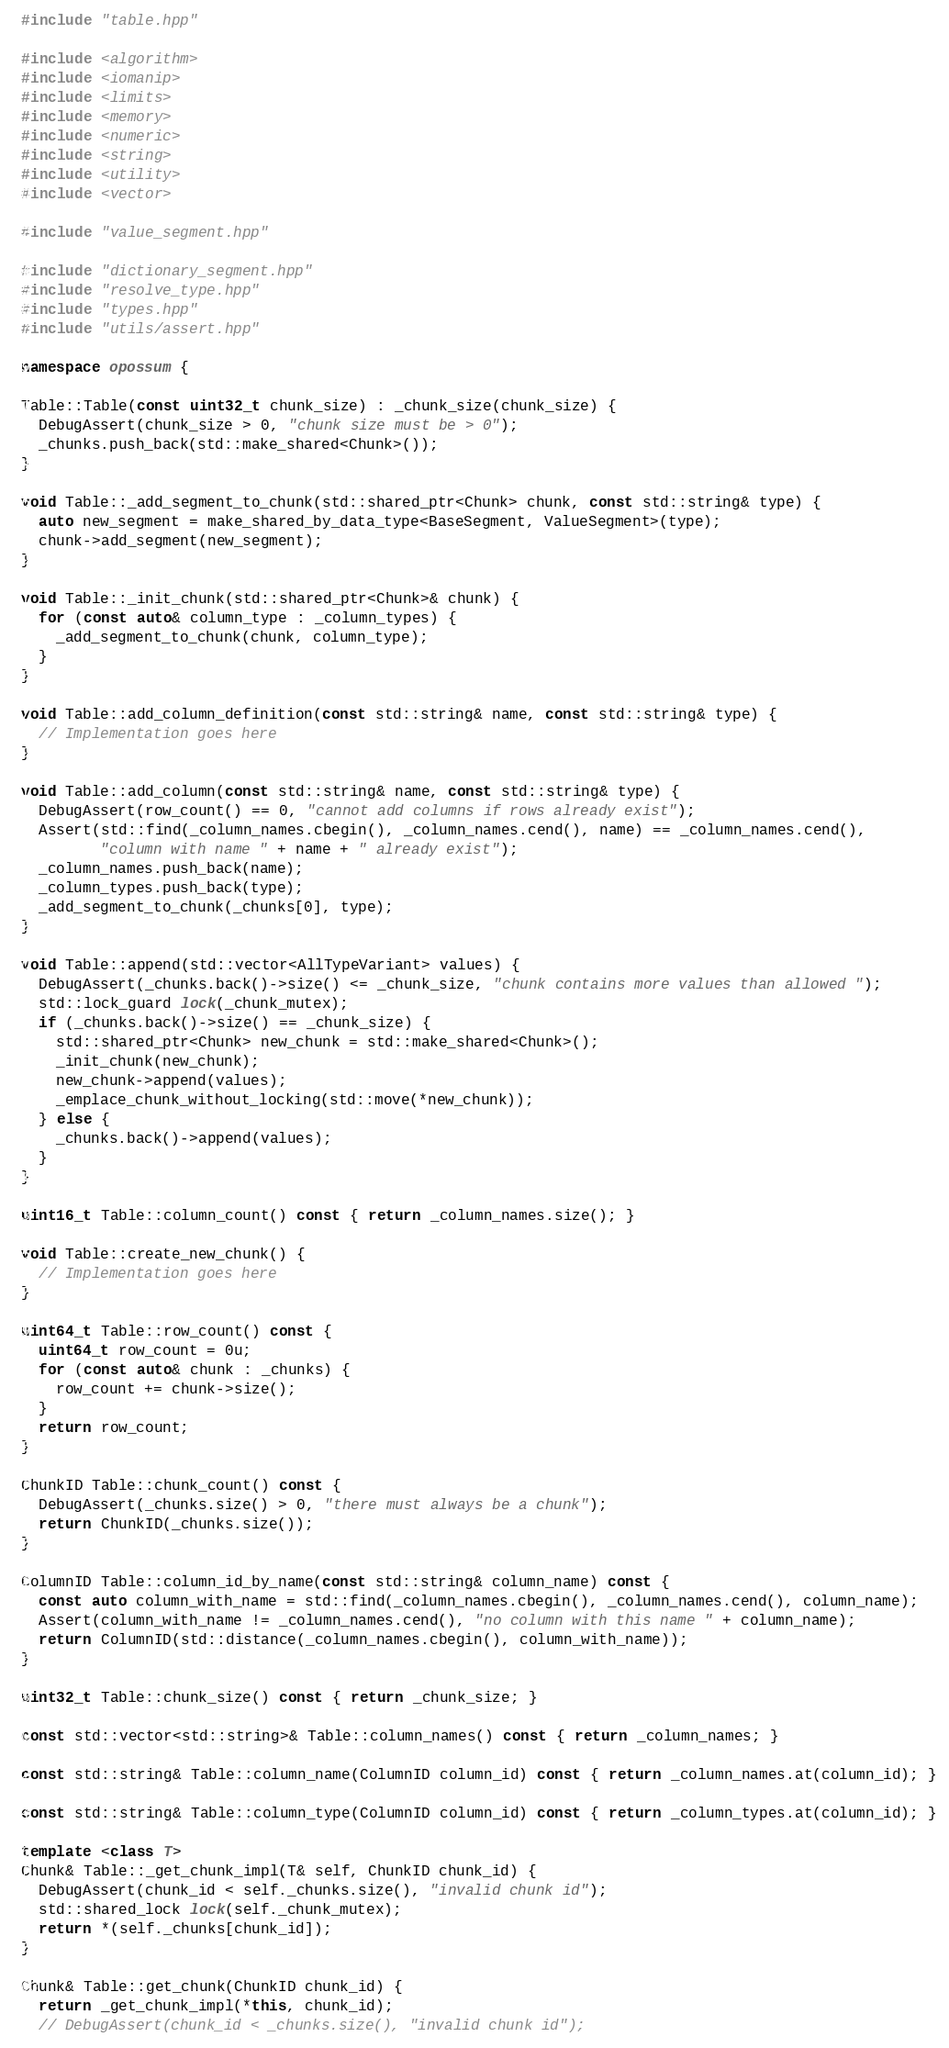<code> <loc_0><loc_0><loc_500><loc_500><_C++_>#include "table.hpp"

#include <algorithm>
#include <iomanip>
#include <limits>
#include <memory>
#include <numeric>
#include <string>
#include <utility>
#include <vector>

#include "value_segment.hpp"

#include "dictionary_segment.hpp"
#include "resolve_type.hpp"
#include "types.hpp"
#include "utils/assert.hpp"

namespace opossum {

Table::Table(const uint32_t chunk_size) : _chunk_size(chunk_size) {
  DebugAssert(chunk_size > 0, "chunk size must be > 0");
  _chunks.push_back(std::make_shared<Chunk>());
}

void Table::_add_segment_to_chunk(std::shared_ptr<Chunk> chunk, const std::string& type) {
  auto new_segment = make_shared_by_data_type<BaseSegment, ValueSegment>(type);
  chunk->add_segment(new_segment);
}

void Table::_init_chunk(std::shared_ptr<Chunk>& chunk) {
  for (const auto& column_type : _column_types) {
    _add_segment_to_chunk(chunk, column_type);
  }
}

void Table::add_column_definition(const std::string& name, const std::string& type) {
  // Implementation goes here
}

void Table::add_column(const std::string& name, const std::string& type) {
  DebugAssert(row_count() == 0, "cannot add columns if rows already exist");
  Assert(std::find(_column_names.cbegin(), _column_names.cend(), name) == _column_names.cend(),
         "column with name " + name + " already exist");
  _column_names.push_back(name);
  _column_types.push_back(type);
  _add_segment_to_chunk(_chunks[0], type);
}

void Table::append(std::vector<AllTypeVariant> values) {
  DebugAssert(_chunks.back()->size() <= _chunk_size, "chunk contains more values than allowed ");
  std::lock_guard lock(_chunk_mutex);
  if (_chunks.back()->size() == _chunk_size) {
    std::shared_ptr<Chunk> new_chunk = std::make_shared<Chunk>();
    _init_chunk(new_chunk);
    new_chunk->append(values);
    _emplace_chunk_without_locking(std::move(*new_chunk));
  } else {
    _chunks.back()->append(values);
  }
}

uint16_t Table::column_count() const { return _column_names.size(); }

void Table::create_new_chunk() {
  // Implementation goes here
}

uint64_t Table::row_count() const {
  uint64_t row_count = 0u;
  for (const auto& chunk : _chunks) {
    row_count += chunk->size();
  }
  return row_count;
}

ChunkID Table::chunk_count() const {
  DebugAssert(_chunks.size() > 0, "there must always be a chunk");
  return ChunkID(_chunks.size());
}

ColumnID Table::column_id_by_name(const std::string& column_name) const {
  const auto column_with_name = std::find(_column_names.cbegin(), _column_names.cend(), column_name);
  Assert(column_with_name != _column_names.cend(), "no column with this name " + column_name);
  return ColumnID(std::distance(_column_names.cbegin(), column_with_name));
}

uint32_t Table::chunk_size() const { return _chunk_size; }

const std::vector<std::string>& Table::column_names() const { return _column_names; }

const std::string& Table::column_name(ColumnID column_id) const { return _column_names.at(column_id); }

const std::string& Table::column_type(ColumnID column_id) const { return _column_types.at(column_id); }

template <class T>
Chunk& Table::_get_chunk_impl(T& self, ChunkID chunk_id) {
  DebugAssert(chunk_id < self._chunks.size(), "invalid chunk id");
  std::shared_lock lock(self._chunk_mutex);
  return *(self._chunks[chunk_id]);
}

Chunk& Table::get_chunk(ChunkID chunk_id) {
  return _get_chunk_impl(*this, chunk_id);
  // DebugAssert(chunk_id < _chunks.size(), "invalid chunk id");</code> 